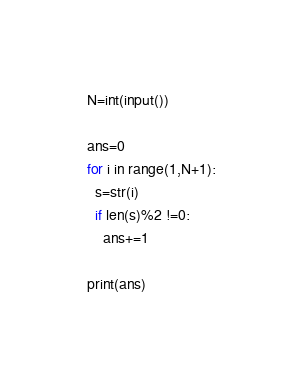Convert code to text. <code><loc_0><loc_0><loc_500><loc_500><_Python_>N=int(input())

ans=0
for i in range(1,N+1):
  s=str(i)
  if len(s)%2 !=0:
    ans+=1
    
print(ans)</code> 